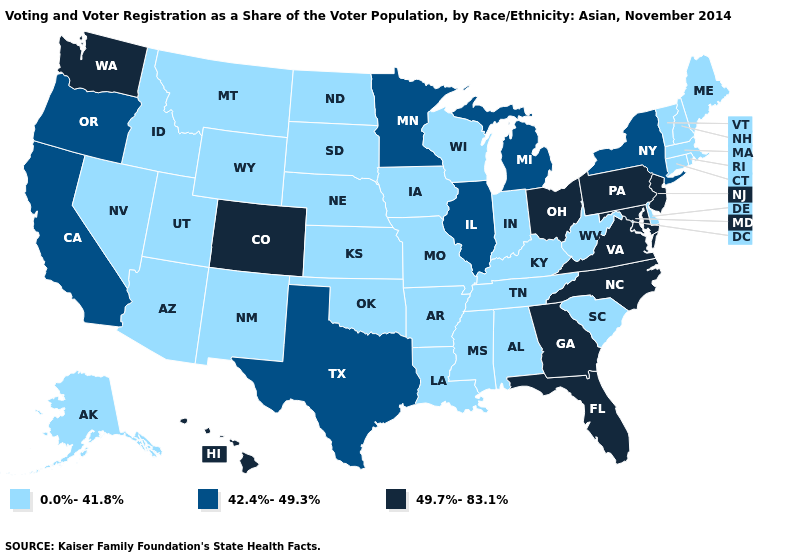Among the states that border Pennsylvania , which have the highest value?
Give a very brief answer. Maryland, New Jersey, Ohio. Which states have the lowest value in the USA?
Quick response, please. Alabama, Alaska, Arizona, Arkansas, Connecticut, Delaware, Idaho, Indiana, Iowa, Kansas, Kentucky, Louisiana, Maine, Massachusetts, Mississippi, Missouri, Montana, Nebraska, Nevada, New Hampshire, New Mexico, North Dakota, Oklahoma, Rhode Island, South Carolina, South Dakota, Tennessee, Utah, Vermont, West Virginia, Wisconsin, Wyoming. What is the highest value in states that border Ohio?
Short answer required. 49.7%-83.1%. What is the lowest value in the USA?
Concise answer only. 0.0%-41.8%. Which states have the highest value in the USA?
Quick response, please. Colorado, Florida, Georgia, Hawaii, Maryland, New Jersey, North Carolina, Ohio, Pennsylvania, Virginia, Washington. Among the states that border Wisconsin , does Illinois have the lowest value?
Write a very short answer. No. What is the highest value in the West ?
Short answer required. 49.7%-83.1%. Is the legend a continuous bar?
Concise answer only. No. Which states have the highest value in the USA?
Concise answer only. Colorado, Florida, Georgia, Hawaii, Maryland, New Jersey, North Carolina, Ohio, Pennsylvania, Virginia, Washington. Among the states that border Pennsylvania , does Maryland have the lowest value?
Give a very brief answer. No. What is the highest value in the USA?
Answer briefly. 49.7%-83.1%. Which states have the lowest value in the USA?
Quick response, please. Alabama, Alaska, Arizona, Arkansas, Connecticut, Delaware, Idaho, Indiana, Iowa, Kansas, Kentucky, Louisiana, Maine, Massachusetts, Mississippi, Missouri, Montana, Nebraska, Nevada, New Hampshire, New Mexico, North Dakota, Oklahoma, Rhode Island, South Carolina, South Dakota, Tennessee, Utah, Vermont, West Virginia, Wisconsin, Wyoming. Name the states that have a value in the range 42.4%-49.3%?
Short answer required. California, Illinois, Michigan, Minnesota, New York, Oregon, Texas. What is the lowest value in states that border Utah?
Quick response, please. 0.0%-41.8%. 